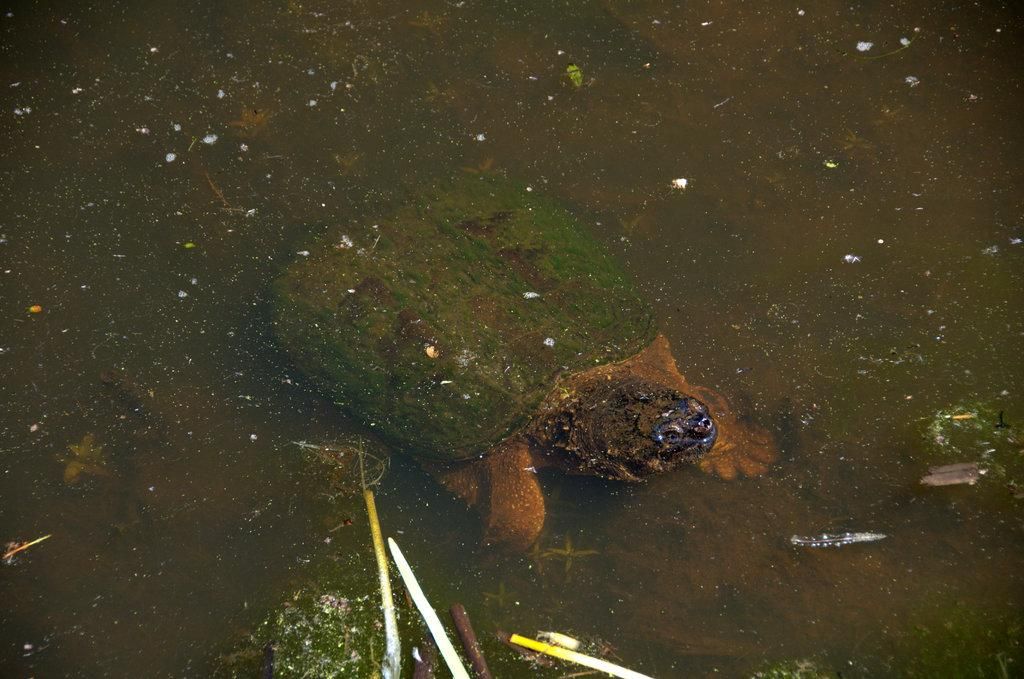What animal is in the image? There is a tortoise in the image. Where is the tortoise located? The tortoise is in the water. What else can be seen in the water? Small plants are present in the water. How would you describe the water's condition? The water appears dirty. How many ducks are in love with the tortoise in the image? There are no ducks present in the image, and therefore no such interaction can be observed. 